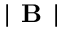<formula> <loc_0><loc_0><loc_500><loc_500>| B |</formula> 